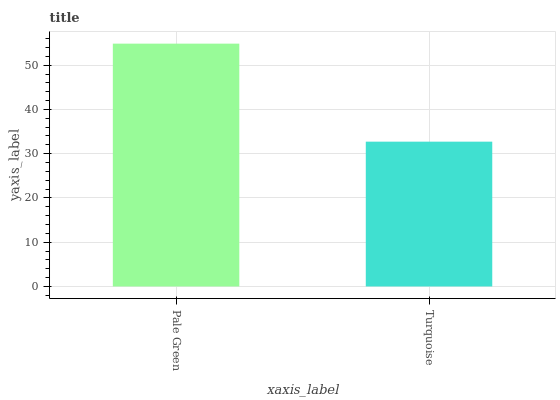Is Turquoise the maximum?
Answer yes or no. No. Is Pale Green greater than Turquoise?
Answer yes or no. Yes. Is Turquoise less than Pale Green?
Answer yes or no. Yes. Is Turquoise greater than Pale Green?
Answer yes or no. No. Is Pale Green less than Turquoise?
Answer yes or no. No. Is Pale Green the high median?
Answer yes or no. Yes. Is Turquoise the low median?
Answer yes or no. Yes. Is Turquoise the high median?
Answer yes or no. No. Is Pale Green the low median?
Answer yes or no. No. 